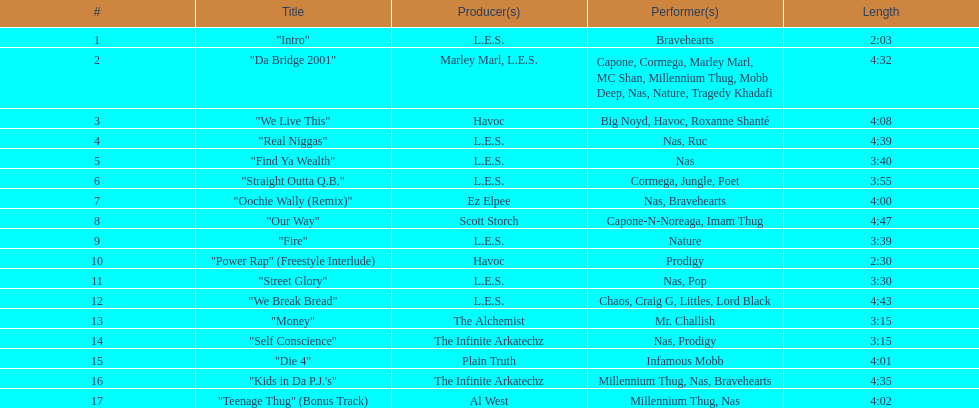How long is the longest track listed? 4:47. 